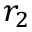<formula> <loc_0><loc_0><loc_500><loc_500>r _ { 2 }</formula> 